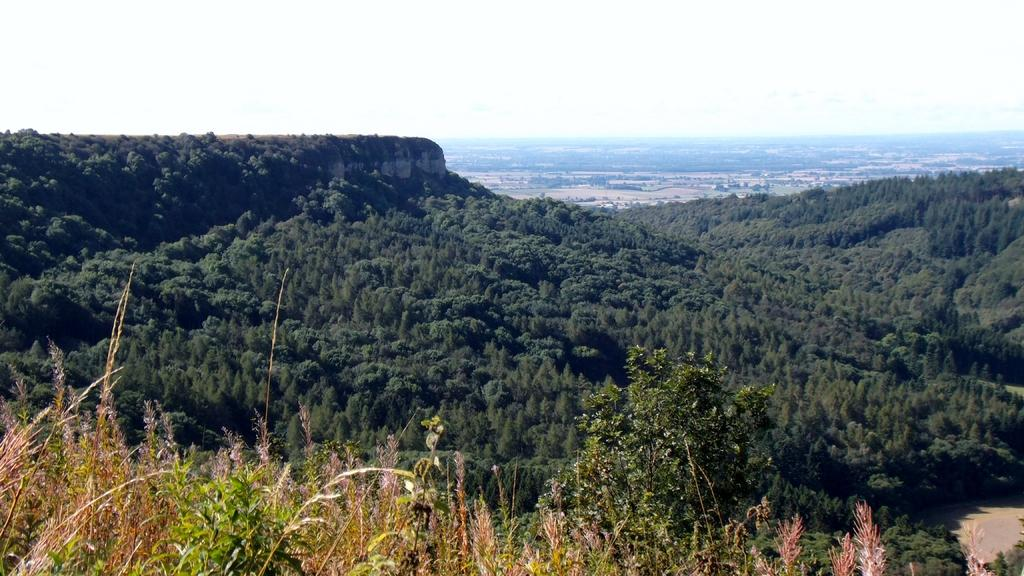Where was the image taken? The image was taken outdoors. What can be seen in the foreground of the image? There are many trees and plants on a hill at the bottom of the image. What type of dock can be seen near the trees in the image? There is no dock present in the image; it is taken outdoors with trees and plants on a hill. 